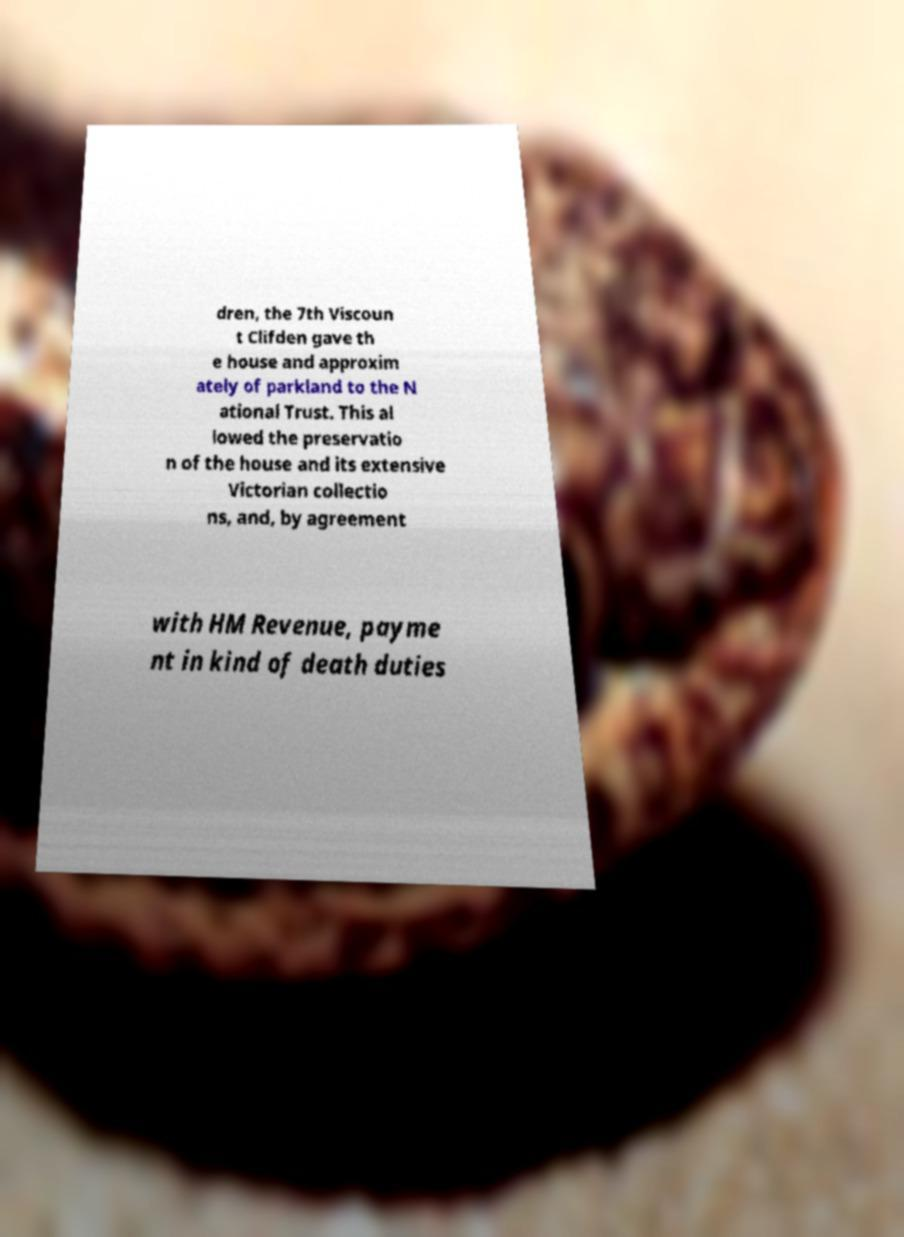Please read and relay the text visible in this image. What does it say? dren, the 7th Viscoun t Clifden gave th e house and approxim ately of parkland to the N ational Trust. This al lowed the preservatio n of the house and its extensive Victorian collectio ns, and, by agreement with HM Revenue, payme nt in kind of death duties 